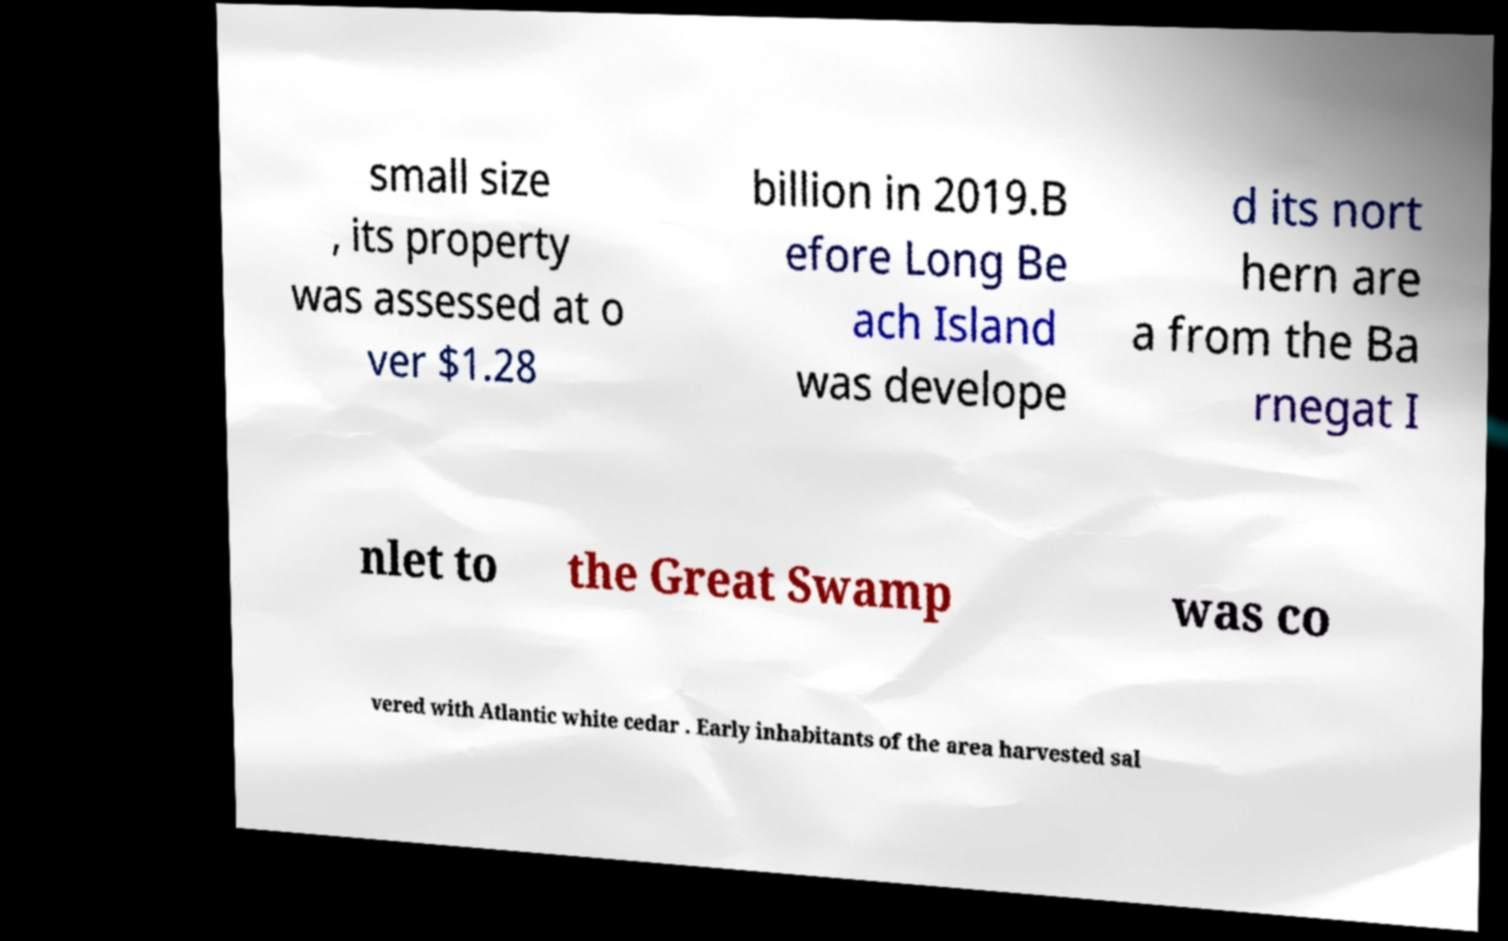There's text embedded in this image that I need extracted. Can you transcribe it verbatim? small size , its property was assessed at o ver $1.28 billion in 2019.B efore Long Be ach Island was develope d its nort hern are a from the Ba rnegat I nlet to the Great Swamp was co vered with Atlantic white cedar . Early inhabitants of the area harvested sal 